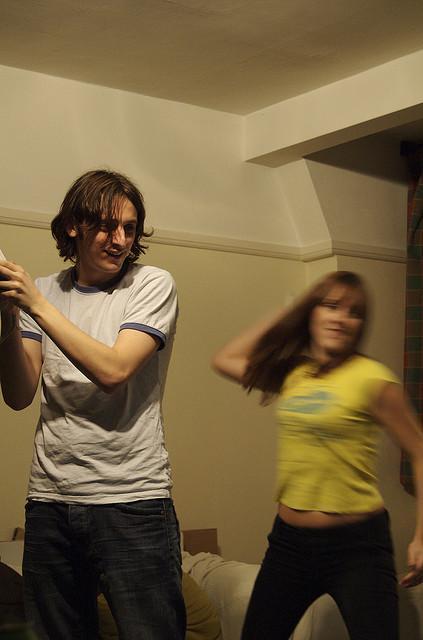How many people are there?
Give a very brief answer. 2. How many white teddy bears in this image?
Give a very brief answer. 0. 